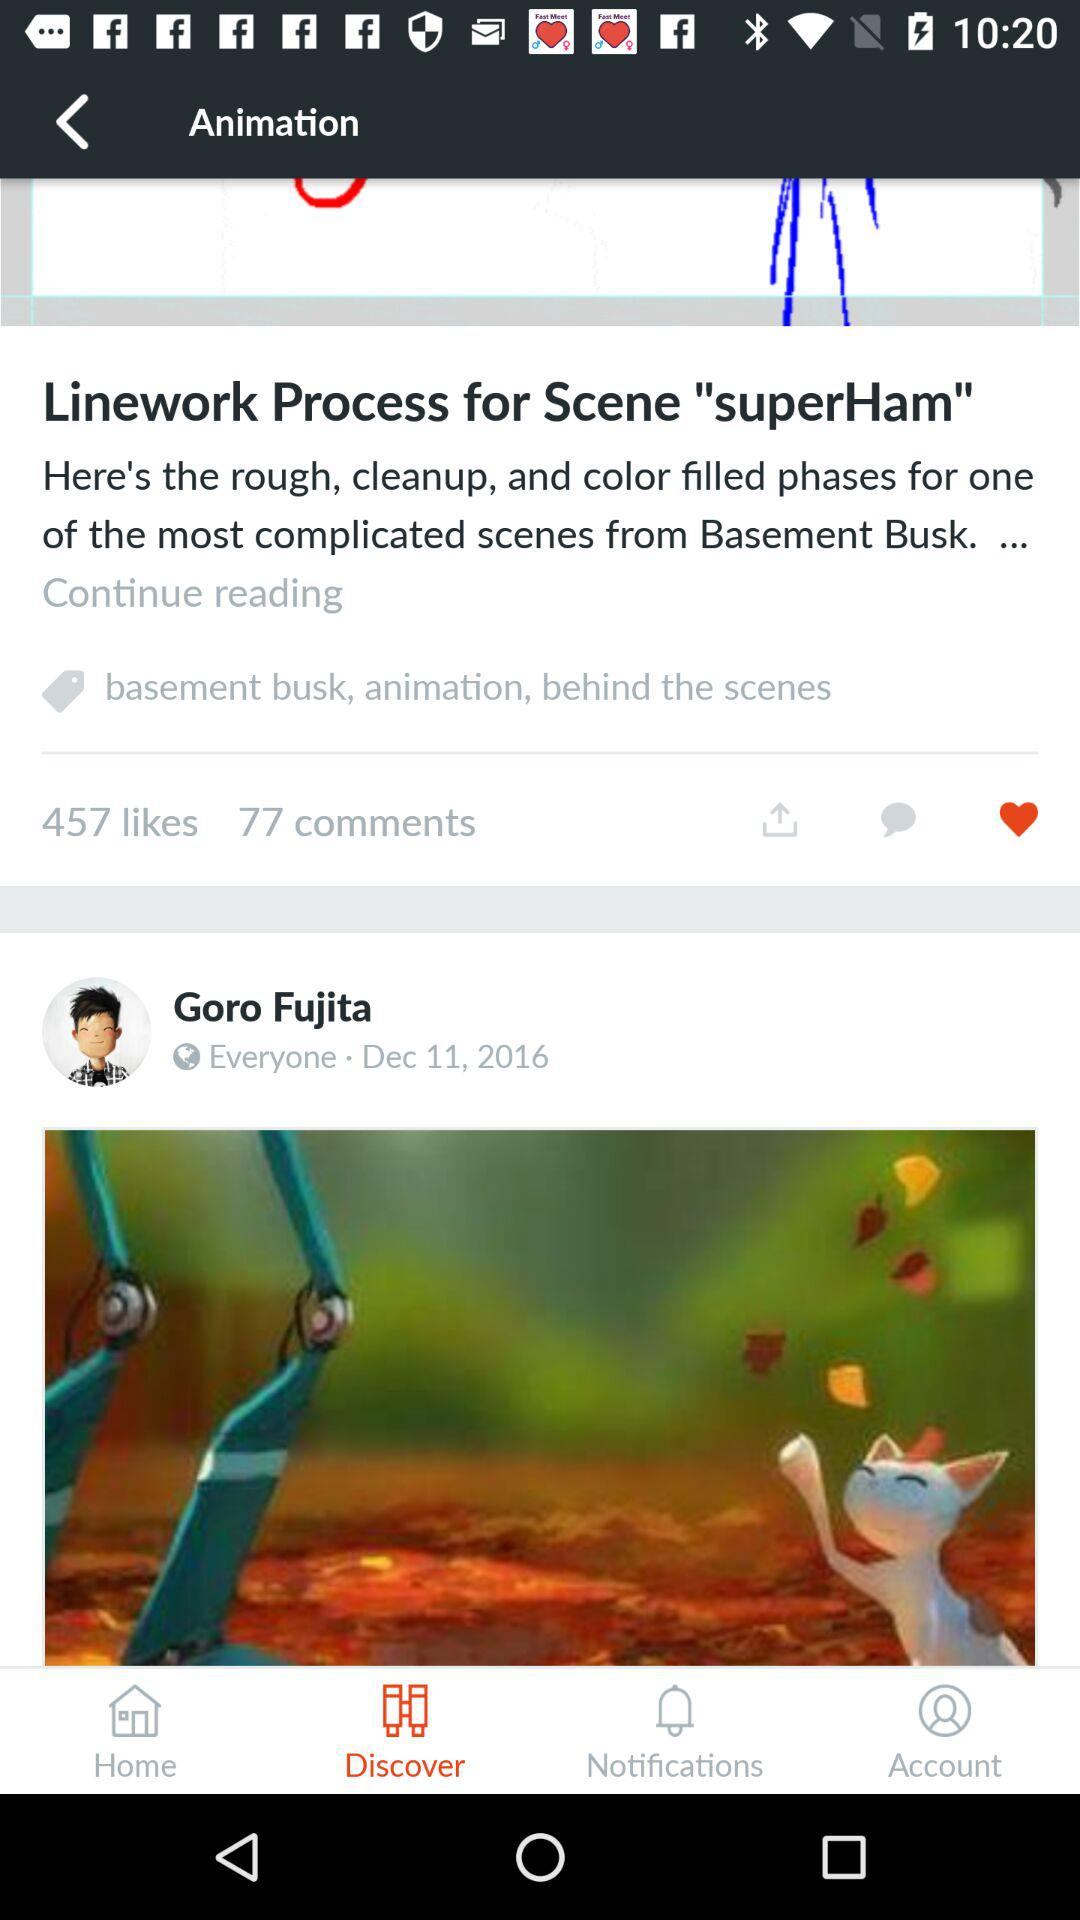How many comments of the "superHam" post? There are 77 comments. 